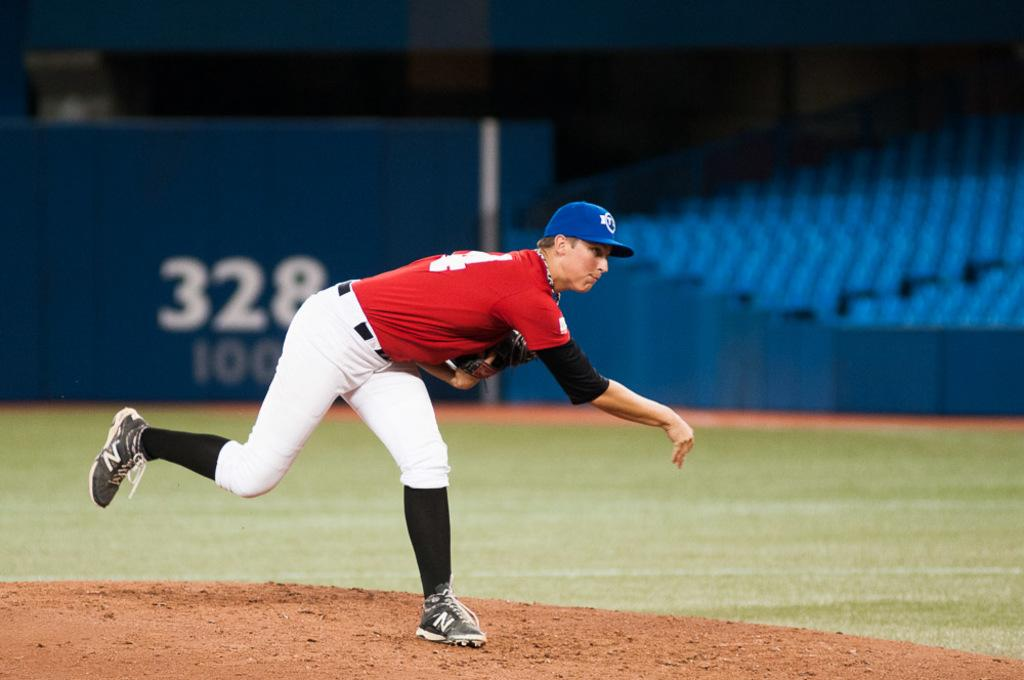<image>
Create a compact narrative representing the image presented. Man is pitching a ball in front of a banner that has the number 328. 